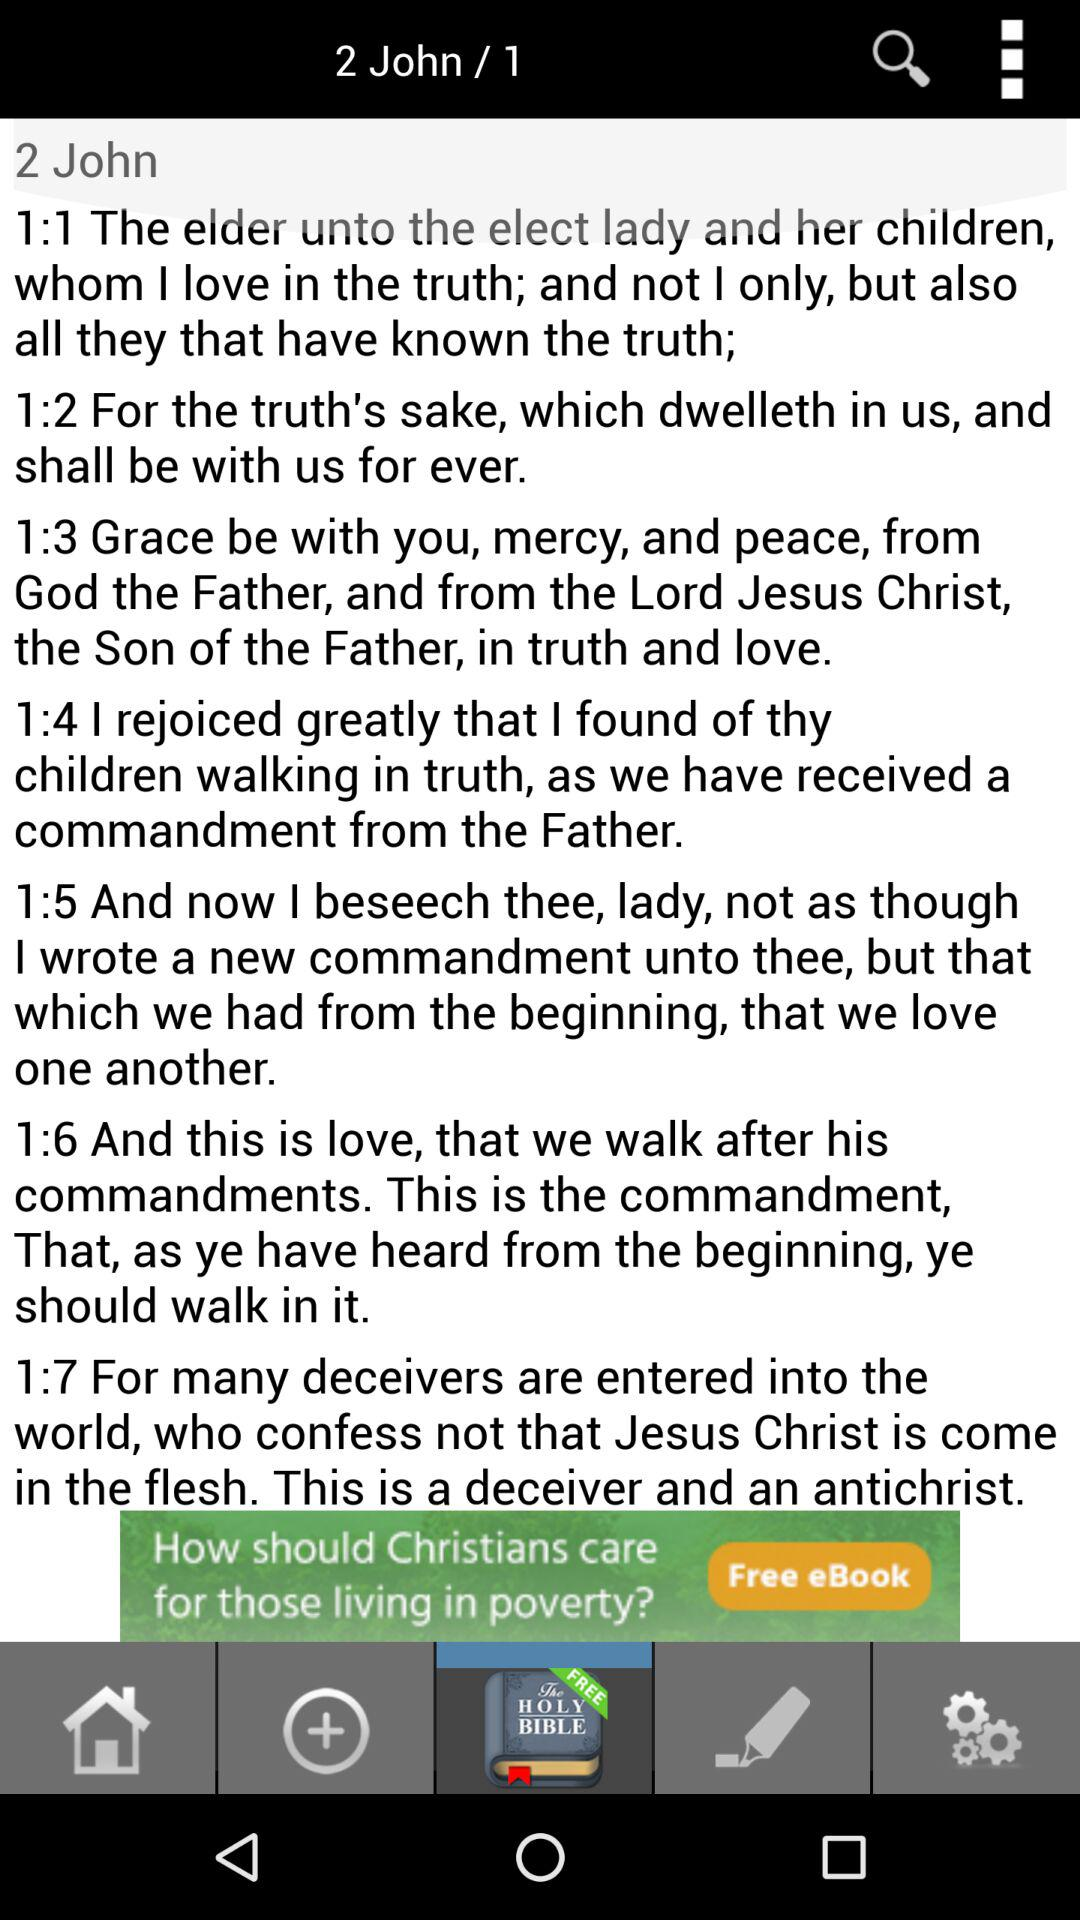How many verses are there in this chapter?
Answer the question using a single word or phrase. 7 